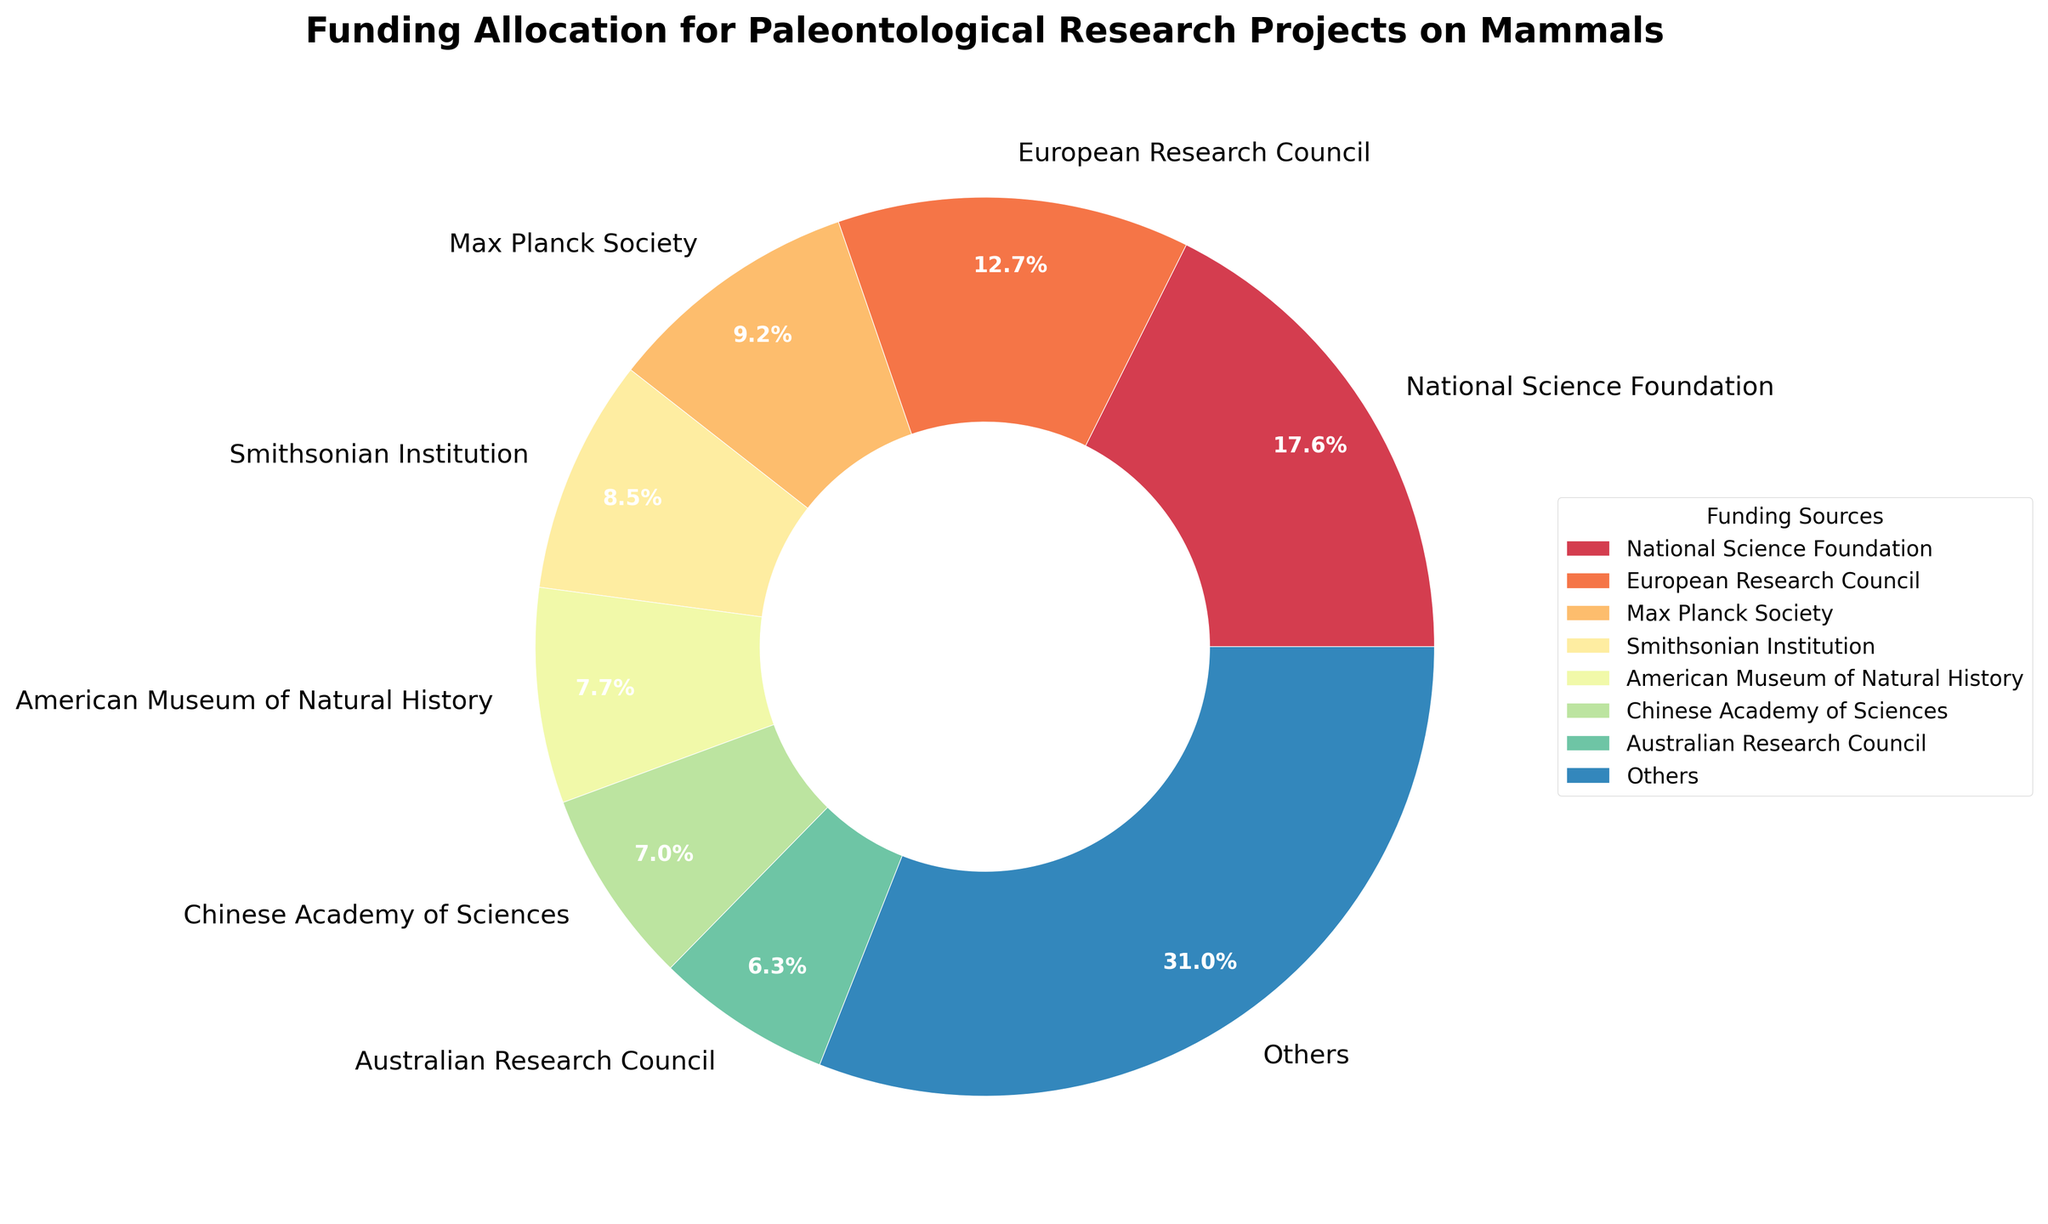Which funding source has the highest allocation? By looking at the pie chart, the largest wedge will represent the highest percentage. Identify which funding source corresponds to this wedge.
Answer: National Science Foundation How many funding sources account for more than 10% of the total funding each? Locate and count wedges that show a percentage greater than 10%.
Answer: 3 What is the combined funding allocation percentage of the Australian Research Council and the European Research Council? Find the percentages for both funding sources from the pie chart and sum them up.
Answer: 7.5% Which funding source has a smaller allocation than the Smithsonian Institution but more than the American Museum of Natural History? Check the percentages for the Smithsonian Institution and American Museum of Natural History, and find the source that fits the criterion between them.
Answer: Max Planck Society How does the total funding allocation from European funding bodies (European Research Council and Max Planck Society) compare to the National Science Foundation? Calculate the sum of the percentages for the European Research Council and Max Planck Society and compare it with the National Science Foundation's percentage.
Answer: Less What percentage of the total funding is allocated by the top three funding sources combined? Identify the top three sources with the largest wedges, sum their percentages from the pie chart.
Answer: 50.0% Which funding source contributing more than 5% is represented by a wedge colored differently from the others (distinctive non-primary color)? By examining the wedges above 5%, identify any wedge with a noticeably different color. The answer must specify the color if its identifiable.
Answer: European Research Council (purple) What’s the approximate difference in funding allocation percentage between the National Geographic Society and the Paleontological Society? Subtract the percentage of the National Geographic Society from that of the Paleontological Society.
Answer: 5.0% What percentage is represented by the category labeled "Others"? Check the pie chart and note the percentage assigned to "Others".
Answer: 12.3% 